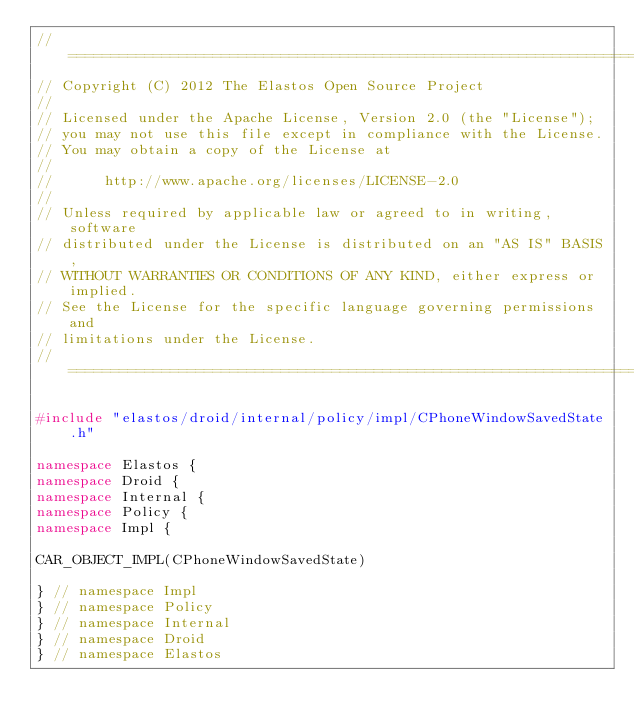<code> <loc_0><loc_0><loc_500><loc_500><_C++_>//=========================================================================
// Copyright (C) 2012 The Elastos Open Source Project
//
// Licensed under the Apache License, Version 2.0 (the "License");
// you may not use this file except in compliance with the License.
// You may obtain a copy of the License at
//
//      http://www.apache.org/licenses/LICENSE-2.0
//
// Unless required by applicable law or agreed to in writing, software
// distributed under the License is distributed on an "AS IS" BASIS,
// WITHOUT WARRANTIES OR CONDITIONS OF ANY KIND, either express or implied.
// See the License for the specific language governing permissions and
// limitations under the License.
//=========================================================================

#include "elastos/droid/internal/policy/impl/CPhoneWindowSavedState.h"

namespace Elastos {
namespace Droid {
namespace Internal {
namespace Policy {
namespace Impl {

CAR_OBJECT_IMPL(CPhoneWindowSavedState)

} // namespace Impl
} // namespace Policy
} // namespace Internal
} // namespace Droid
} // namespace Elastos
</code> 